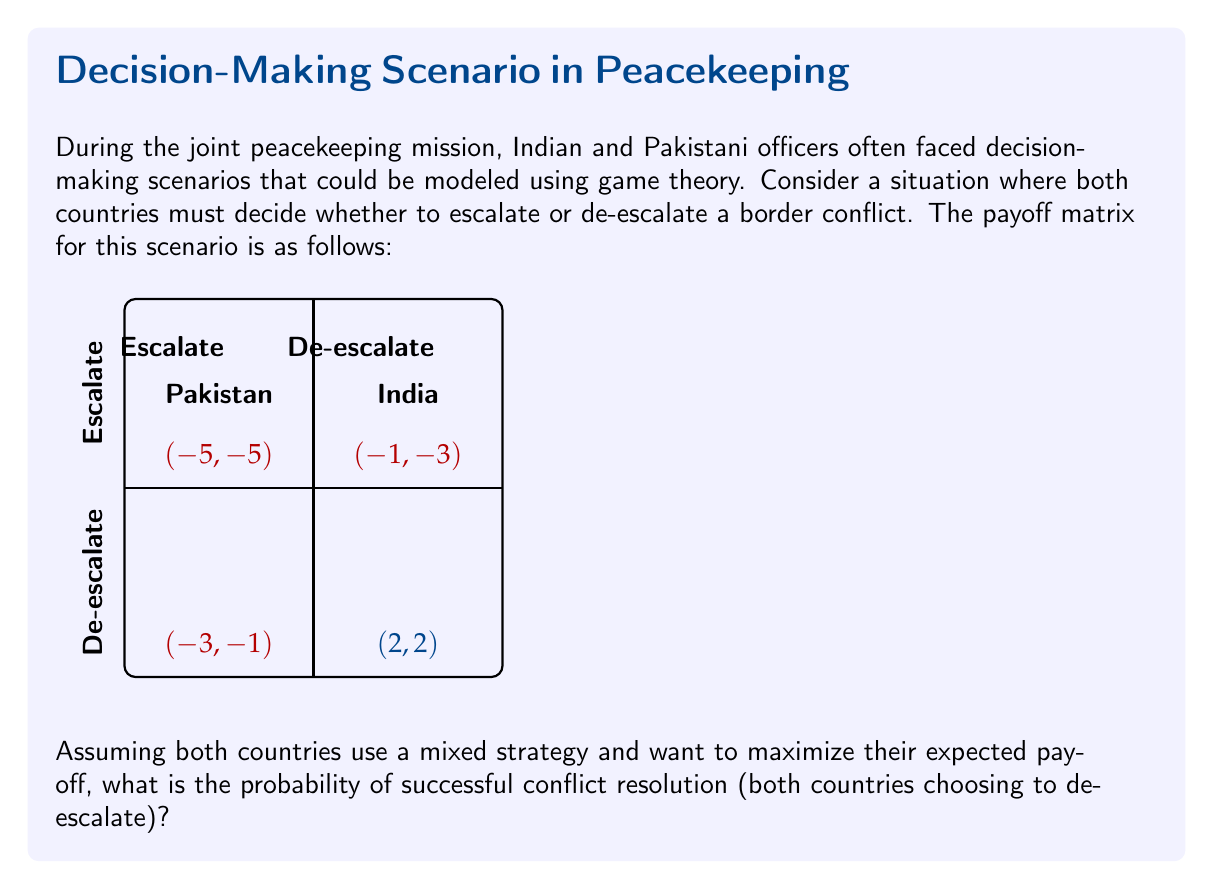Teach me how to tackle this problem. To solve this problem, we need to follow these steps:

1) First, let's define the variables:
   Let $p$ be the probability of India choosing to de-escalate
   Let $q$ be the probability of Pakistan choosing to de-escalate

2) For a mixed strategy equilibrium, each country should be indifferent between their two options. Let's start with India:

   Expected payoff for India when escalating: $-5(1-q) + (-3)q$
   Expected payoff for India when de-escalating: $(-1)(1-q) + 2q$

   Setting these equal:
   $-5 + 2q = -1 + 3q$
   $-4 = q$
   $q = 0.8$

3) Now for Pakistan:

   Expected payoff for Pakistan when escalating: $-5(1-p) + (-1)p$
   Expected payoff for Pakistan when de-escalating: $(-3)(1-p) + 2p$

   Setting these equal:
   $-5 + 4p = -3 + 5p$
   $-2 = p$
   $p = 0.8$

4) The probability of successful conflict resolution is the probability of both countries choosing to de-escalate:

   $P(\text{both de-escalate}) = p * q = 0.8 * 0.8 = 0.64$

Therefore, the probability of successful conflict resolution is 0.64 or 64%.
Answer: $0.64$ 